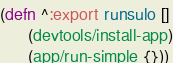Convert code to text. <code><loc_0><loc_0><loc_500><loc_500><_Clojure_>(defn ^:export runsulo []
      (devtools/install-app)
      (app/run-simple {}))
</code> 